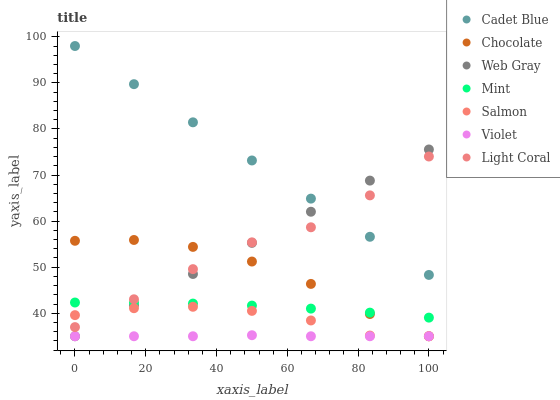Does Violet have the minimum area under the curve?
Answer yes or no. Yes. Does Cadet Blue have the maximum area under the curve?
Answer yes or no. Yes. Does Salmon have the minimum area under the curve?
Answer yes or no. No. Does Salmon have the maximum area under the curve?
Answer yes or no. No. Is Cadet Blue the smoothest?
Answer yes or no. Yes. Is Light Coral the roughest?
Answer yes or no. Yes. Is Salmon the smoothest?
Answer yes or no. No. Is Salmon the roughest?
Answer yes or no. No. Does Salmon have the lowest value?
Answer yes or no. Yes. Does Light Coral have the lowest value?
Answer yes or no. No. Does Cadet Blue have the highest value?
Answer yes or no. Yes. Does Salmon have the highest value?
Answer yes or no. No. Is Violet less than Light Coral?
Answer yes or no. Yes. Is Cadet Blue greater than Salmon?
Answer yes or no. Yes. Does Mint intersect Light Coral?
Answer yes or no. Yes. Is Mint less than Light Coral?
Answer yes or no. No. Is Mint greater than Light Coral?
Answer yes or no. No. Does Violet intersect Light Coral?
Answer yes or no. No. 